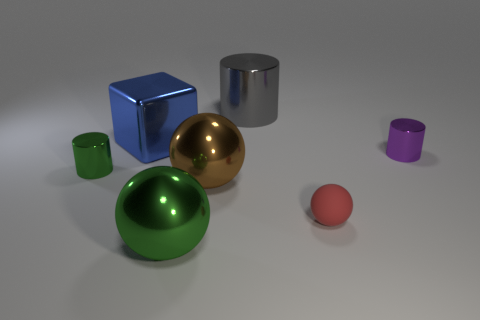Is the number of purple metal objects greater than the number of cylinders? Upon examination of the image, there is a single purple metal object, which appears to be a cylinder as well. Therefore, it isn't accurate to say the number of purple metal objects is greater than the number of cylinders, seeing as they are both represented by the same object in this case. 